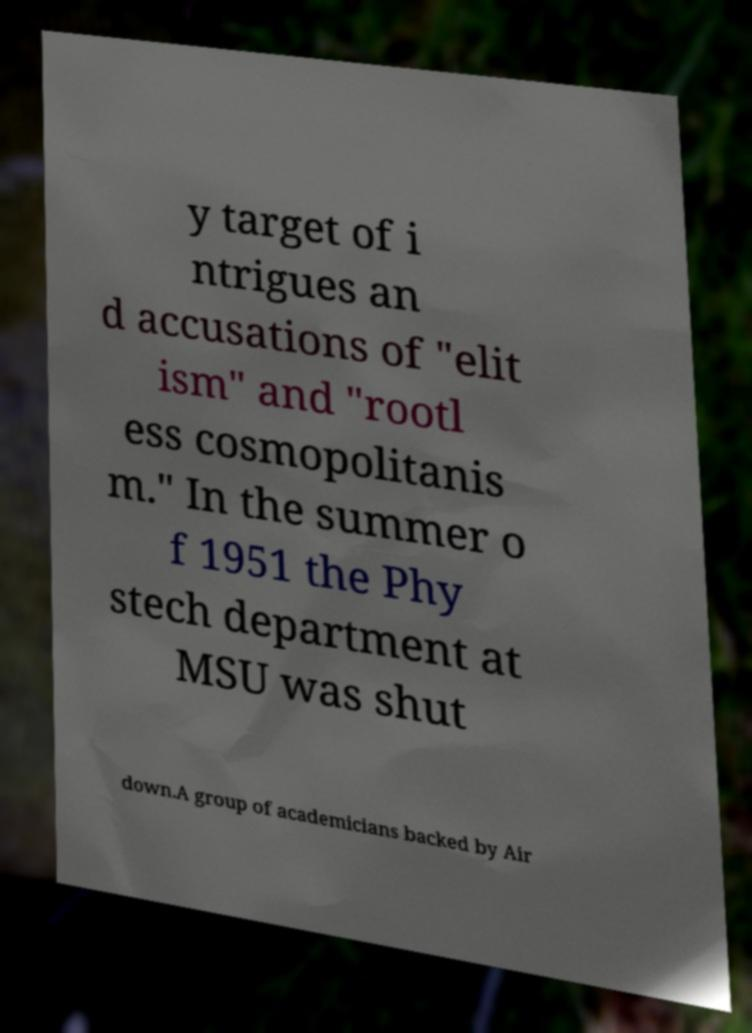Could you assist in decoding the text presented in this image and type it out clearly? y target of i ntrigues an d accusations of "elit ism" and "rootl ess cosmopolitanis m." In the summer o f 1951 the Phy stech department at MSU was shut down.A group of academicians backed by Air 